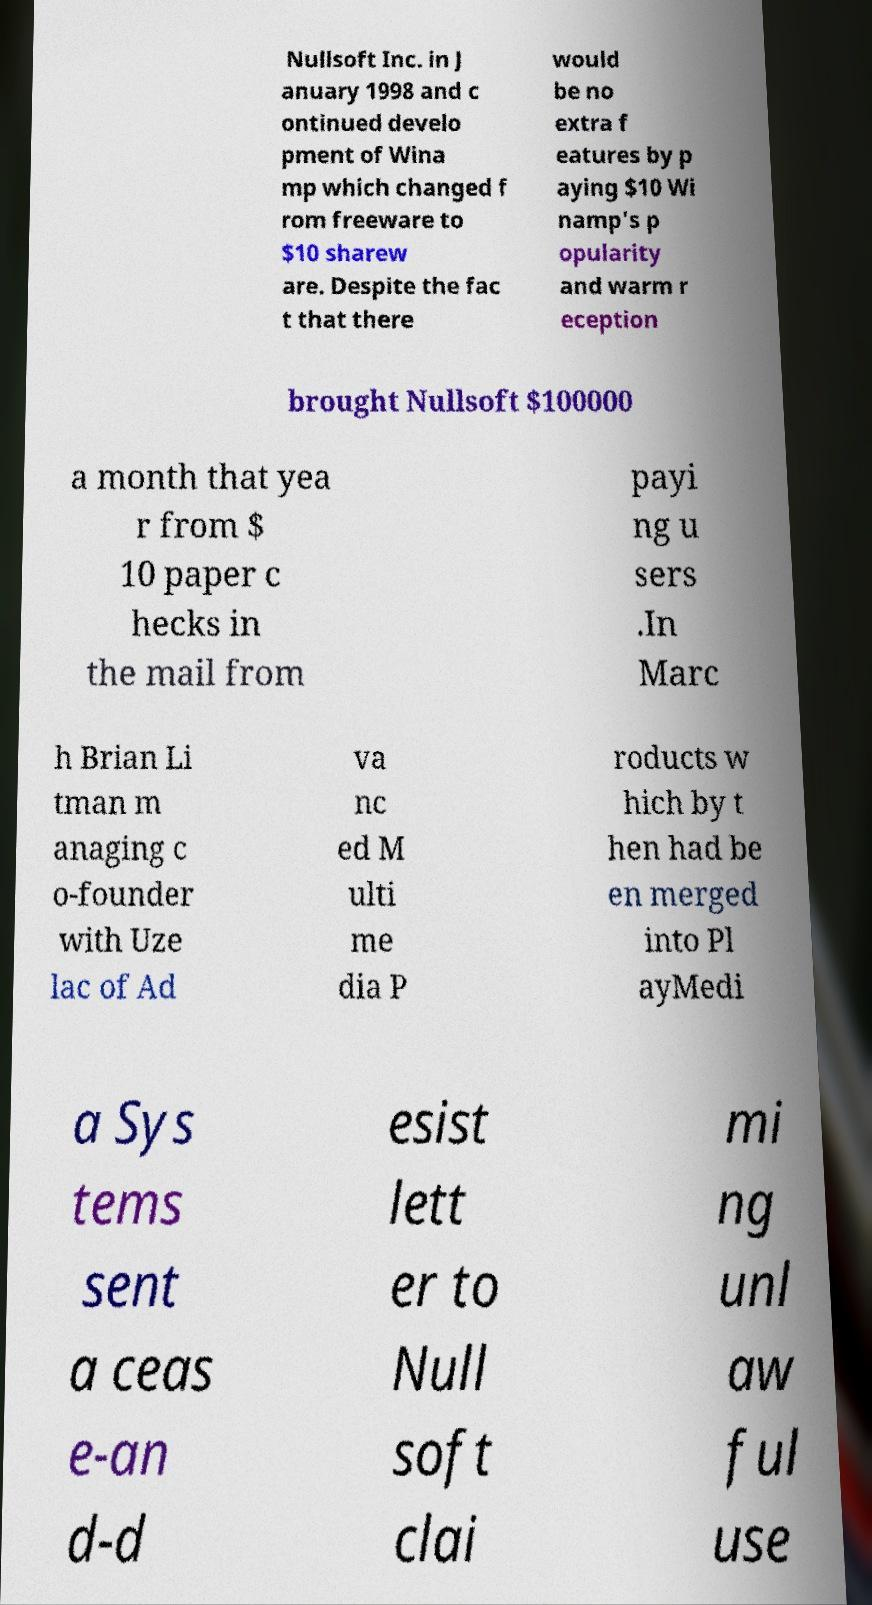Can you accurately transcribe the text from the provided image for me? Nullsoft Inc. in J anuary 1998 and c ontinued develo pment of Wina mp which changed f rom freeware to $10 sharew are. Despite the fac t that there would be no extra f eatures by p aying $10 Wi namp's p opularity and warm r eception brought Nullsoft $100000 a month that yea r from $ 10 paper c hecks in the mail from payi ng u sers .In Marc h Brian Li tman m anaging c o-founder with Uze lac of Ad va nc ed M ulti me dia P roducts w hich by t hen had be en merged into Pl ayMedi a Sys tems sent a ceas e-an d-d esist lett er to Null soft clai mi ng unl aw ful use 